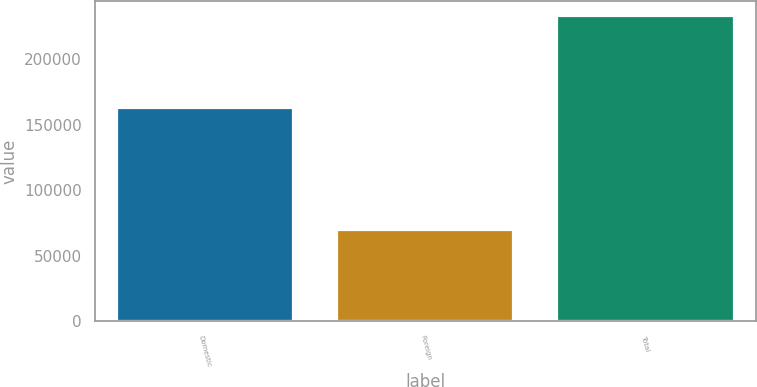Convert chart. <chart><loc_0><loc_0><loc_500><loc_500><bar_chart><fcel>Domestic<fcel>Foreign<fcel>Total<nl><fcel>162880<fcel>69996<fcel>232876<nl></chart> 